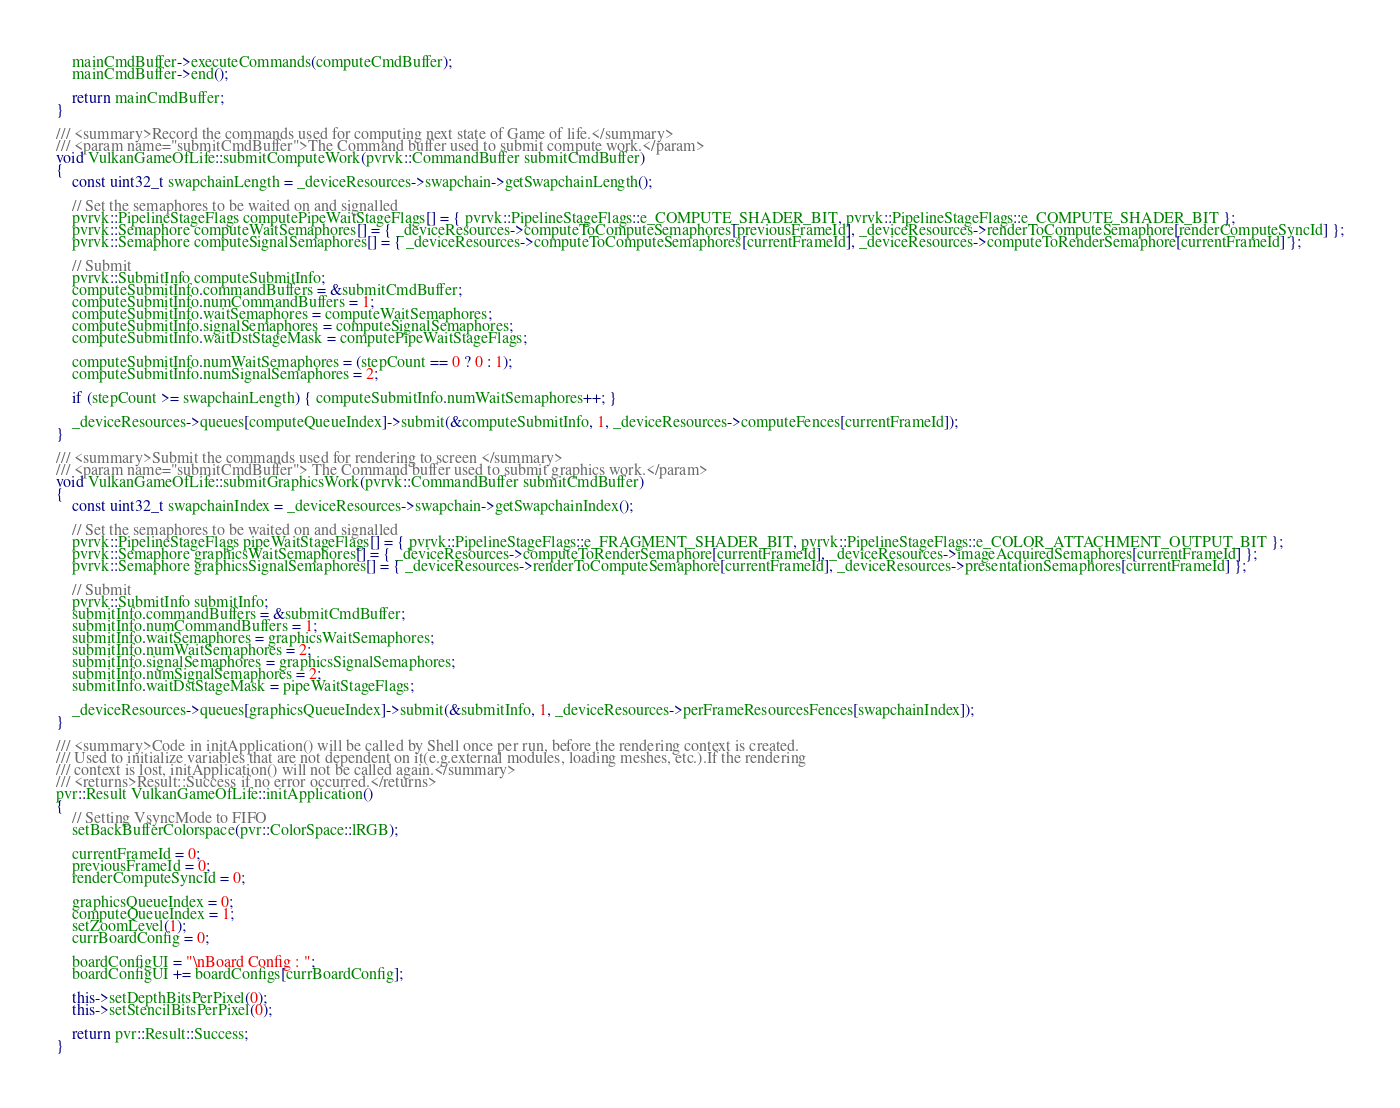<code> <loc_0><loc_0><loc_500><loc_500><_C++_>	mainCmdBuffer->executeCommands(computeCmdBuffer);
	mainCmdBuffer->end();

	return mainCmdBuffer;
}

/// <summary>Record the commands used for computing next state of Game of life.</summary>
/// <param name="submitCmdBuffer">The Command buffer used to submit compute work.</param>
void VulkanGameOfLife::submitComputeWork(pvrvk::CommandBuffer submitCmdBuffer)
{
	const uint32_t swapchainLength = _deviceResources->swapchain->getSwapchainLength();

	// Set the semaphores to be waited on and signalled
	pvrvk::PipelineStageFlags computePipeWaitStageFlags[] = { pvrvk::PipelineStageFlags::e_COMPUTE_SHADER_BIT, pvrvk::PipelineStageFlags::e_COMPUTE_SHADER_BIT };
	pvrvk::Semaphore computeWaitSemaphores[] = { _deviceResources->computeToComputeSemaphores[previousFrameId], _deviceResources->renderToComputeSemaphore[renderComputeSyncId] };
	pvrvk::Semaphore computeSignalSemaphores[] = { _deviceResources->computeToComputeSemaphores[currentFrameId], _deviceResources->computeToRenderSemaphore[currentFrameId] };

	// Submit
	pvrvk::SubmitInfo computeSubmitInfo;
	computeSubmitInfo.commandBuffers = &submitCmdBuffer;
	computeSubmitInfo.numCommandBuffers = 1;
	computeSubmitInfo.waitSemaphores = computeWaitSemaphores;
	computeSubmitInfo.signalSemaphores = computeSignalSemaphores;
	computeSubmitInfo.waitDstStageMask = computePipeWaitStageFlags;

	computeSubmitInfo.numWaitSemaphores = (stepCount == 0 ? 0 : 1);
	computeSubmitInfo.numSignalSemaphores = 2;

	if (stepCount >= swapchainLength) { computeSubmitInfo.numWaitSemaphores++; }

	_deviceResources->queues[computeQueueIndex]->submit(&computeSubmitInfo, 1, _deviceResources->computeFences[currentFrameId]);
}

/// <summary>Submit the commands used for rendering to screen </summary>
/// <param name="submitCmdBuffer"> The Command buffer used to submit graphics work.</param>
void VulkanGameOfLife::submitGraphicsWork(pvrvk::CommandBuffer submitCmdBuffer)
{
	const uint32_t swapchainIndex = _deviceResources->swapchain->getSwapchainIndex();

	// Set the semaphores to be waited on and signalled
	pvrvk::PipelineStageFlags pipeWaitStageFlags[] = { pvrvk::PipelineStageFlags::e_FRAGMENT_SHADER_BIT, pvrvk::PipelineStageFlags::e_COLOR_ATTACHMENT_OUTPUT_BIT };
	pvrvk::Semaphore graphicsWaitSemaphores[] = { _deviceResources->computeToRenderSemaphore[currentFrameId], _deviceResources->imageAcquiredSemaphores[currentFrameId] };
	pvrvk::Semaphore graphicsSignalSemaphores[] = { _deviceResources->renderToComputeSemaphore[currentFrameId], _deviceResources->presentationSemaphores[currentFrameId] };

	// Submit
	pvrvk::SubmitInfo submitInfo;
	submitInfo.commandBuffers = &submitCmdBuffer;
	submitInfo.numCommandBuffers = 1;
	submitInfo.waitSemaphores = graphicsWaitSemaphores;
	submitInfo.numWaitSemaphores = 2;
	submitInfo.signalSemaphores = graphicsSignalSemaphores;
	submitInfo.numSignalSemaphores = 2;
	submitInfo.waitDstStageMask = pipeWaitStageFlags;

	_deviceResources->queues[graphicsQueueIndex]->submit(&submitInfo, 1, _deviceResources->perFrameResourcesFences[swapchainIndex]);
}

/// <summary>Code in initApplication() will be called by Shell once per run, before the rendering context is created.
/// Used to initialize variables that are not dependent on it(e.g.external modules, loading meshes, etc.).If the rendering
/// context is lost, initApplication() will not be called again.</summary>
/// <returns>Result::Success if no error occurred.</returns>
pvr::Result VulkanGameOfLife::initApplication()
{
	// Setting VsyncMode to FIFO
	setBackBufferColorspace(pvr::ColorSpace::lRGB);

	currentFrameId = 0;
	previousFrameId = 0;
	renderComputeSyncId = 0;

	graphicsQueueIndex = 0;
	computeQueueIndex = 1;
	setZoomLevel(1);
	currBoardConfig = 0;

	boardConfigUI = "\nBoard Config : ";
	boardConfigUI += boardConfigs[currBoardConfig];

	this->setDepthBitsPerPixel(0);
	this->setStencilBitsPerPixel(0);

	return pvr::Result::Success;
}
</code> 